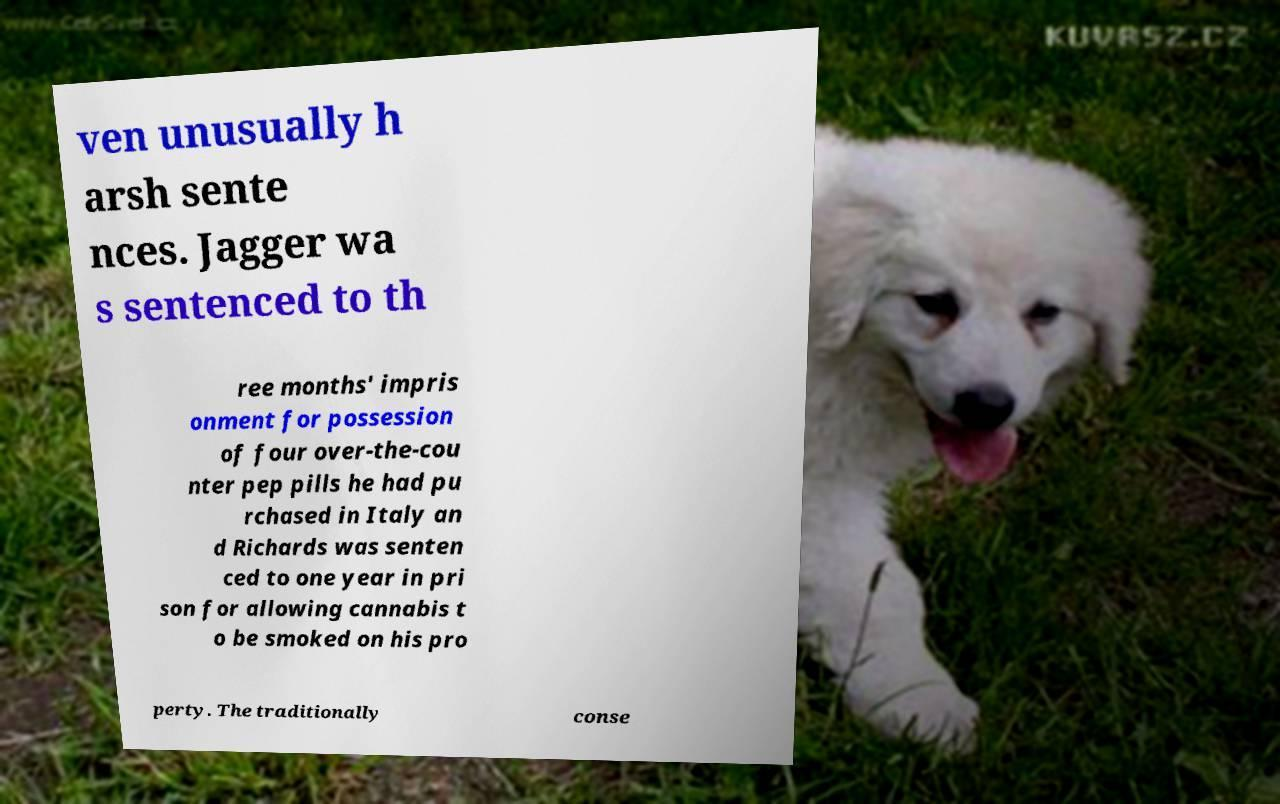For documentation purposes, I need the text within this image transcribed. Could you provide that? ven unusually h arsh sente nces. Jagger wa s sentenced to th ree months' impris onment for possession of four over-the-cou nter pep pills he had pu rchased in Italy an d Richards was senten ced to one year in pri son for allowing cannabis t o be smoked on his pro perty. The traditionally conse 